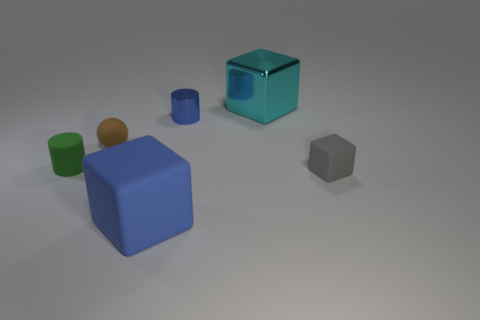Subtract all cyan cubes. Subtract all purple cylinders. How many cubes are left? 2 Add 2 small green matte objects. How many objects exist? 8 Subtract all spheres. How many objects are left? 5 Add 6 cylinders. How many cylinders are left? 8 Add 5 gray cubes. How many gray cubes exist? 6 Subtract 0 green spheres. How many objects are left? 6 Subtract all small cyan matte balls. Subtract all rubber spheres. How many objects are left? 5 